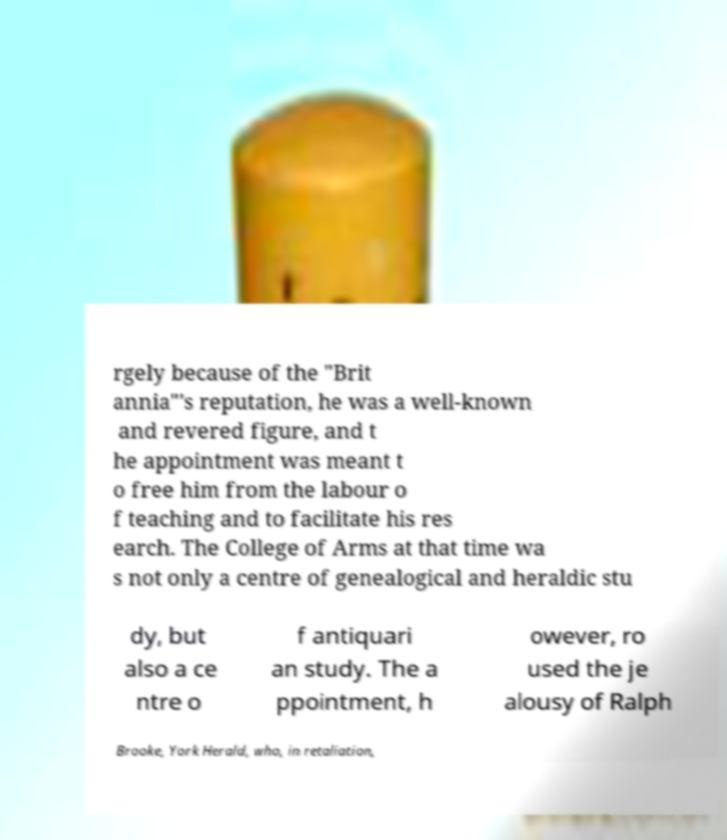There's text embedded in this image that I need extracted. Can you transcribe it verbatim? rgely because of the "Brit annia"'s reputation, he was a well-known and revered figure, and t he appointment was meant t o free him from the labour o f teaching and to facilitate his res earch. The College of Arms at that time wa s not only a centre of genealogical and heraldic stu dy, but also a ce ntre o f antiquari an study. The a ppointment, h owever, ro used the je alousy of Ralph Brooke, York Herald, who, in retaliation, 